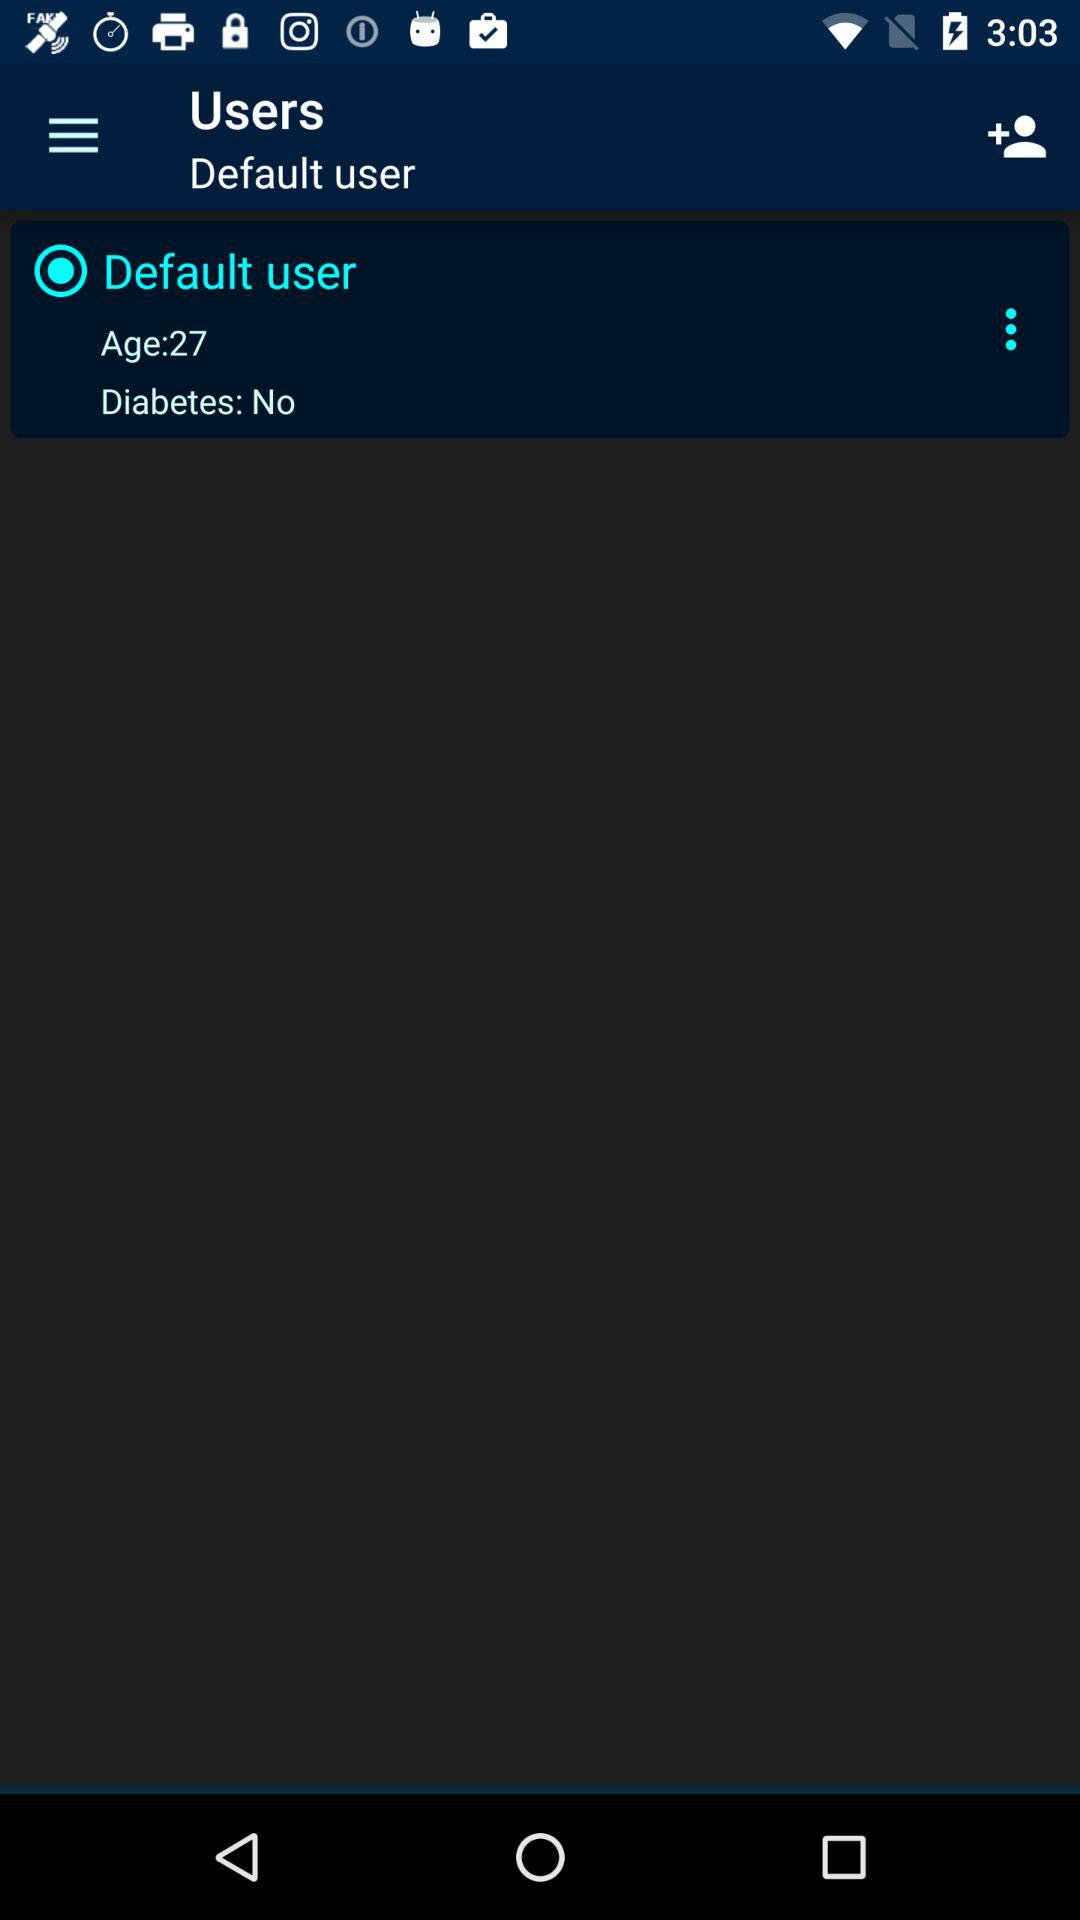What user is selected? The selected user is "Default user". 